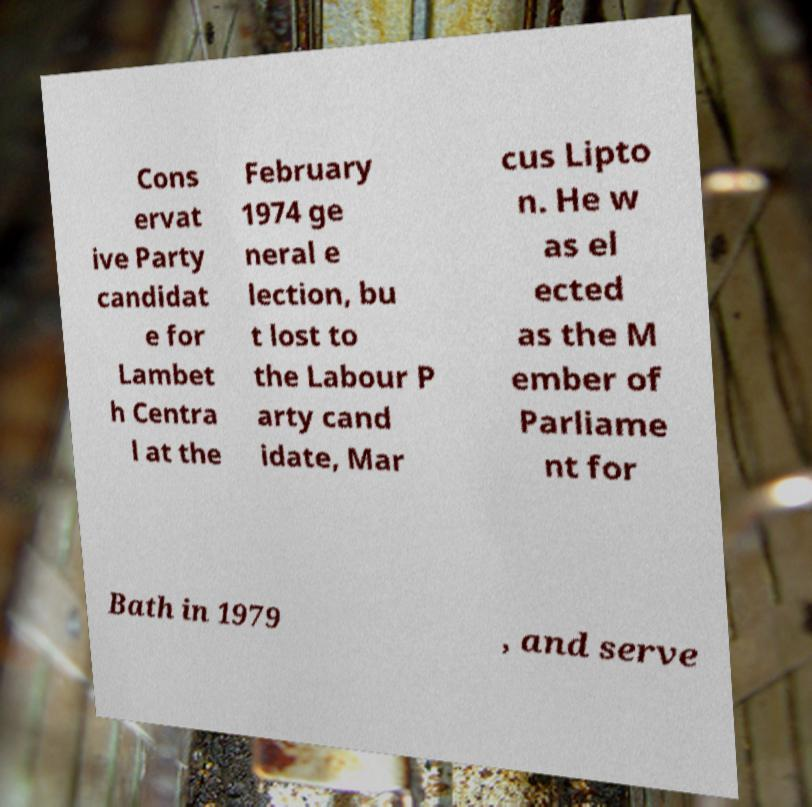What messages or text are displayed in this image? I need them in a readable, typed format. Cons ervat ive Party candidat e for Lambet h Centra l at the February 1974 ge neral e lection, bu t lost to the Labour P arty cand idate, Mar cus Lipto n. He w as el ected as the M ember of Parliame nt for Bath in 1979 , and serve 